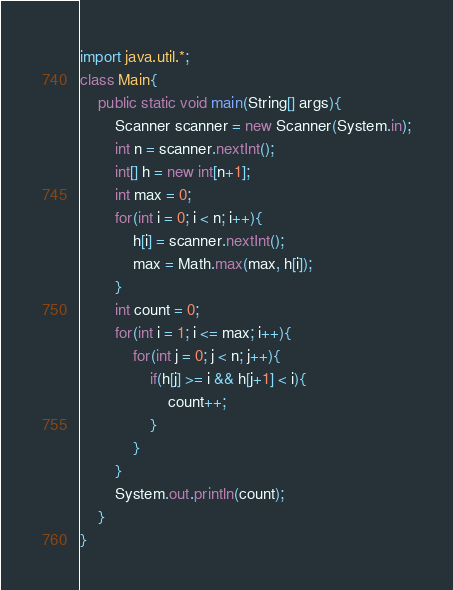<code> <loc_0><loc_0><loc_500><loc_500><_Java_>import java.util.*;
class Main{
    public static void main(String[] args){
        Scanner scanner = new Scanner(System.in);
        int n = scanner.nextInt();
        int[] h = new int[n+1];
        int max = 0;
        for(int i = 0; i < n; i++){
            h[i] = scanner.nextInt();
            max = Math.max(max, h[i]);
        }
        int count = 0;
        for(int i = 1; i <= max; i++){
            for(int j = 0; j < n; j++){
                if(h[j] >= i && h[j+1] < i){
                    count++;
                }
            }
        }
        System.out.println(count);
    }
}</code> 